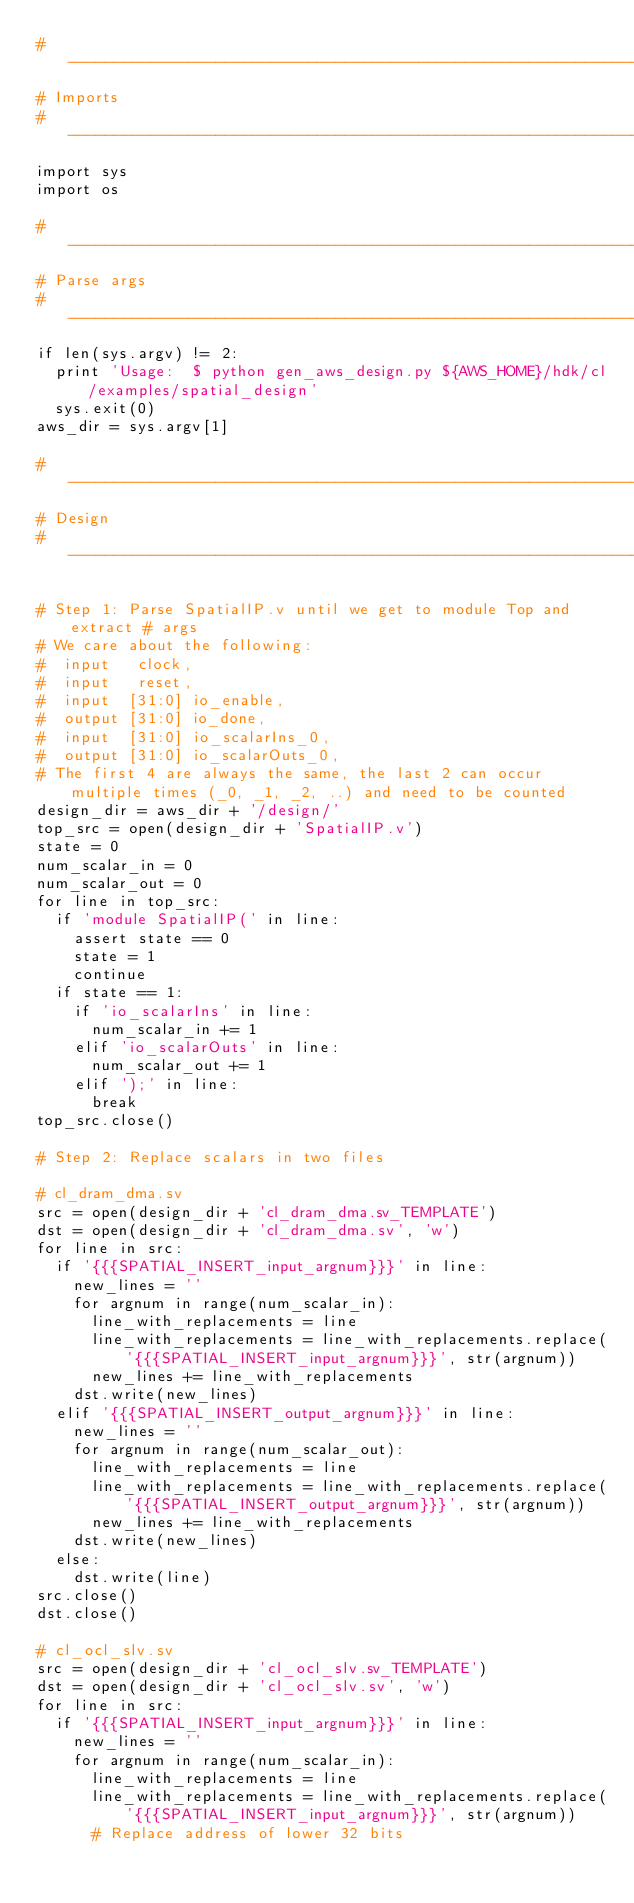Convert code to text. <code><loc_0><loc_0><loc_500><loc_500><_Python_># ------------------------------------------------------------------------------
# Imports
# ------------------------------------------------------------------------------
import sys
import os

# ------------------------------------------------------------------------------
# Parse args
# ------------------------------------------------------------------------------
if len(sys.argv) != 2:
  print 'Usage:  $ python gen_aws_design.py ${AWS_HOME}/hdk/cl/examples/spatial_design'
  sys.exit(0)
aws_dir = sys.argv[1]

# ------------------------------------------------------------------------------
# Design
# ------------------------------------------------------------------------------

# Step 1: Parse SpatialIP.v until we get to module Top and extract # args
# We care about the following:
#  input   clock,
#  input   reset,
#  input  [31:0] io_enable,
#  output [31:0] io_done,
#  input  [31:0] io_scalarIns_0,
#  output [31:0] io_scalarOuts_0,
# The first 4 are always the same, the last 2 can occur multiple times (_0, _1, _2, ..) and need to be counted
design_dir = aws_dir + '/design/'
top_src = open(design_dir + 'SpatialIP.v')
state = 0
num_scalar_in = 0
num_scalar_out = 0
for line in top_src:
  if 'module SpatialIP(' in line:
    assert state == 0
    state = 1
    continue
  if state == 1:
    if 'io_scalarIns' in line:
      num_scalar_in += 1
    elif 'io_scalarOuts' in line:
      num_scalar_out += 1
    elif ');' in line:
      break      
top_src.close()

# Step 2: Replace scalars in two files

# cl_dram_dma.sv
src = open(design_dir + 'cl_dram_dma.sv_TEMPLATE')
dst = open(design_dir + 'cl_dram_dma.sv', 'w')
for line in src:
  if '{{{SPATIAL_INSERT_input_argnum}}}' in line:
    new_lines = ''
    for argnum in range(num_scalar_in):
      line_with_replacements = line
      line_with_replacements = line_with_replacements.replace('{{{SPATIAL_INSERT_input_argnum}}}', str(argnum))
      new_lines += line_with_replacements
    dst.write(new_lines)
  elif '{{{SPATIAL_INSERT_output_argnum}}}' in line:
    new_lines = ''
    for argnum in range(num_scalar_out):
      line_with_replacements = line
      line_with_replacements = line_with_replacements.replace('{{{SPATIAL_INSERT_output_argnum}}}', str(argnum))
      new_lines += line_with_replacements
    dst.write(new_lines)
  else:
    dst.write(line)
src.close()
dst.close()

# cl_ocl_slv.sv
src = open(design_dir + 'cl_ocl_slv.sv_TEMPLATE')
dst = open(design_dir + 'cl_ocl_slv.sv', 'w')
for line in src:
  if '{{{SPATIAL_INSERT_input_argnum}}}' in line:
    new_lines = ''
    for argnum in range(num_scalar_in):
      line_with_replacements = line
      line_with_replacements = line_with_replacements.replace('{{{SPATIAL_INSERT_input_argnum}}}', str(argnum))
      # Replace address of lower 32 bits</code> 